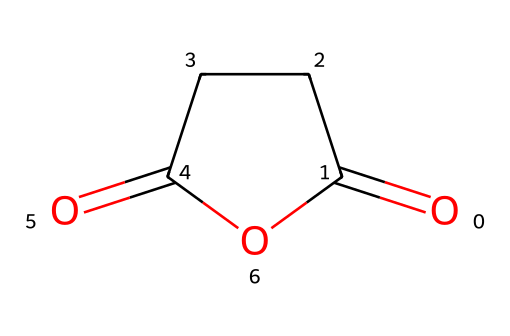What is the name of the chemical represented by this SMILES? The SMILES notation `O=C1CCC(=O)O1` corresponds to succinic anhydride, which is an acid anhydride derived from succinic acid.
Answer: succinic anhydride How many carbon atoms are present in this chemical? By examining the structure implied by the SMILES, there are four carbon atoms in the cyclic structure of succinic anhydride.
Answer: four How many oxygen atoms can be found in this molecule? The SMILES shows two carbonyl groups (C=O) and one oxygen in the ring, totaling three oxygen atoms in the structure.
Answer: three What type of chemical is represented by this structure? The presence of two acyl groups and the cyclic ring structure indicates that it is an acid anhydride.
Answer: acid anhydride Which functional group indicates that this chemical is an anhydride? The presence of the two carbonyl groups (C=O) that are connected through an oxygen atom in the cyclic structure is characteristic of anhydrides.
Answer: carbonyl groups Is this compound considered to be a flame retardant? Yes, succinic anhydride is utilized as an additive in flame retardants for materials like those used in electronics, including TV set-top boxes.
Answer: yes 